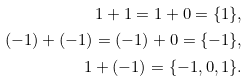Convert formula to latex. <formula><loc_0><loc_0><loc_500><loc_500>1 + 1 = 1 + 0 = \{ 1 \} , \\ ( - 1 ) + ( - 1 ) = ( - 1 ) + 0 = \{ - 1 \} , \\ 1 + ( - 1 ) = \{ - 1 , 0 , 1 \} .</formula> 